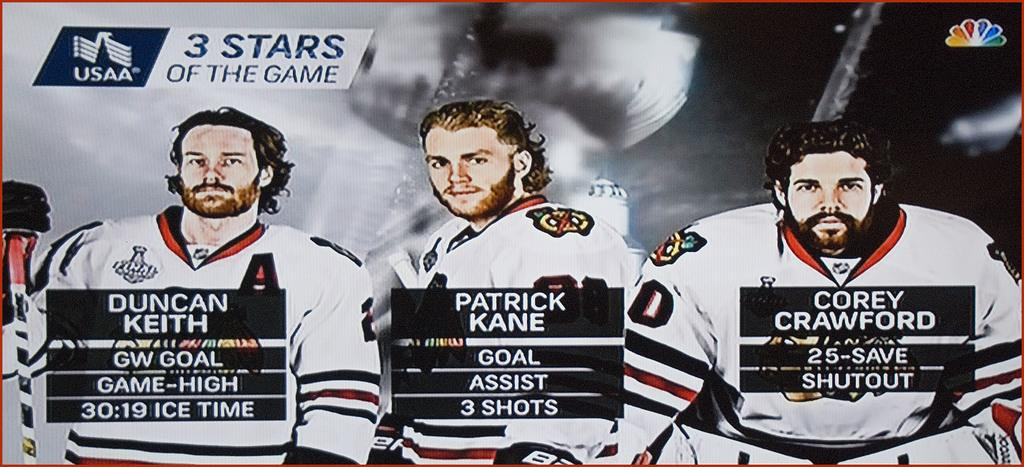<image>
Write a terse but informative summary of the picture. The three stars of an ice hockey game. 